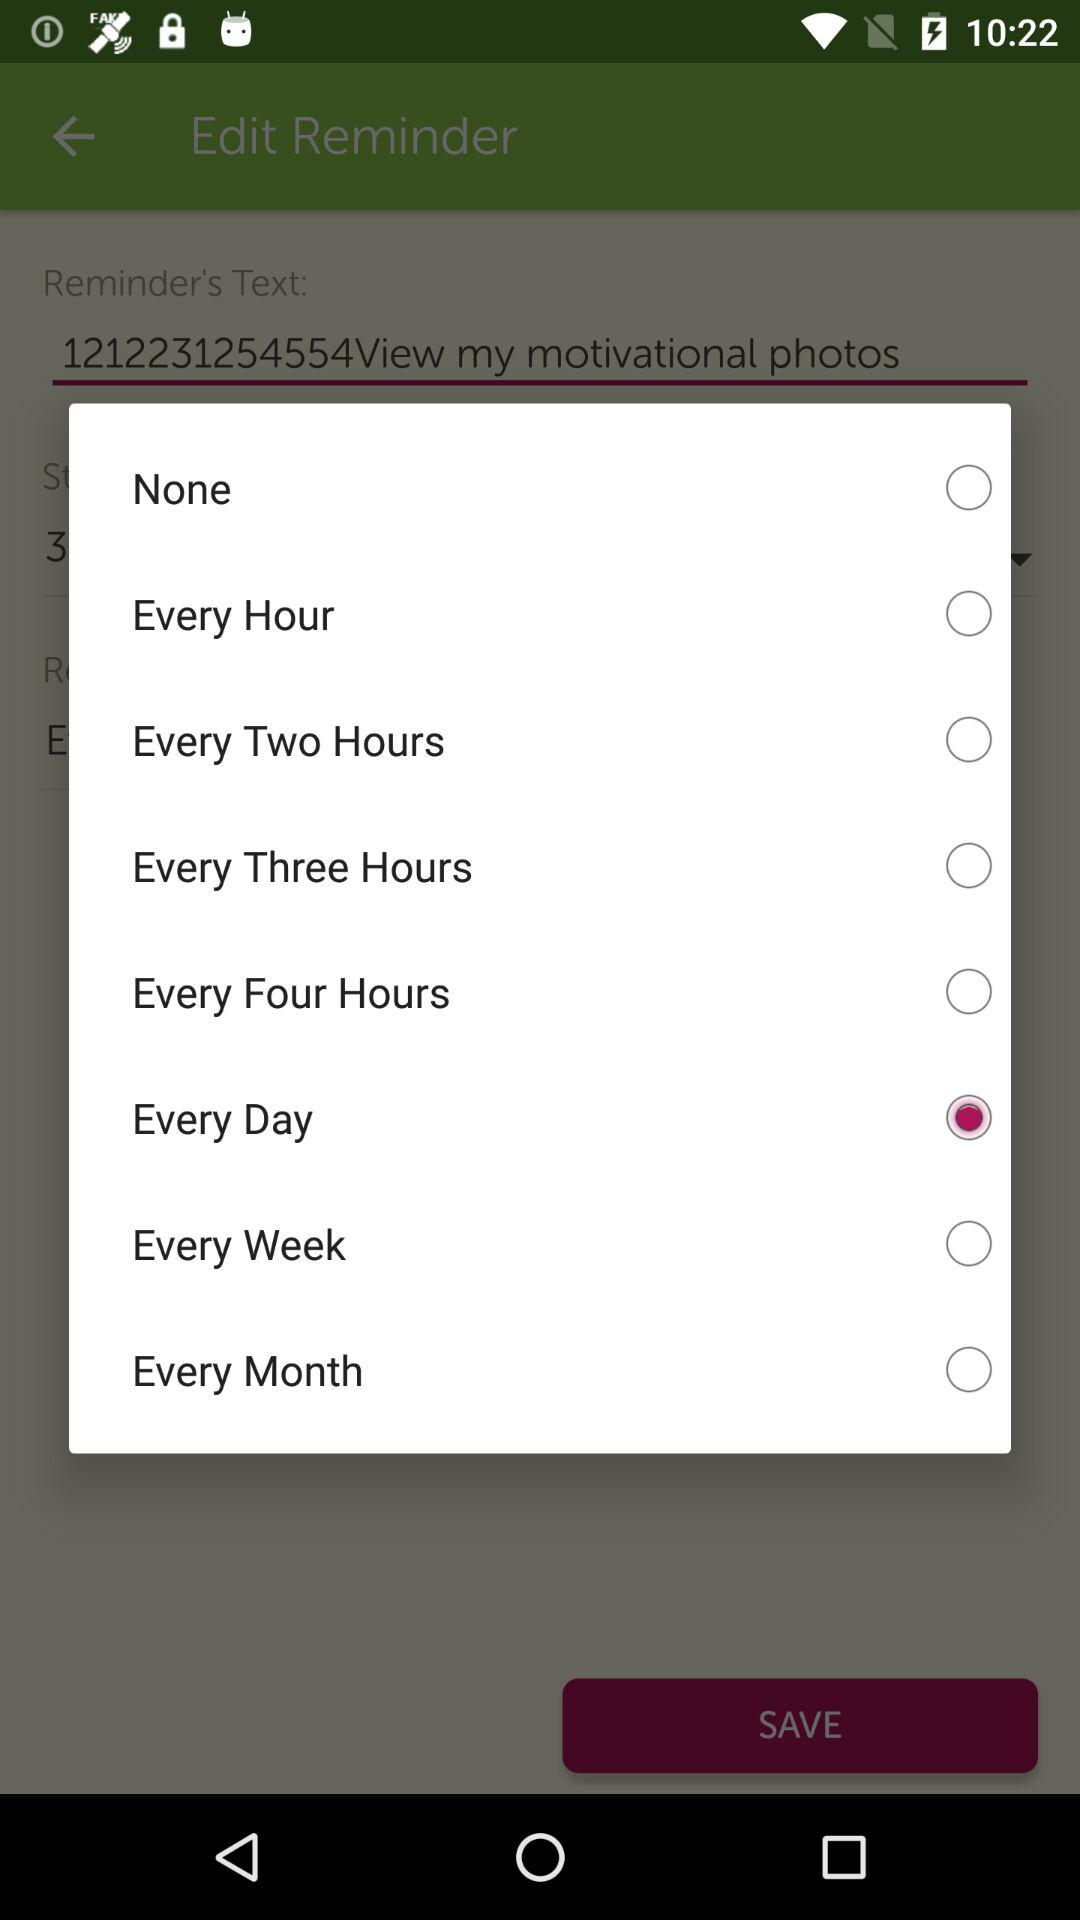What option has been selected? The selected option is "Every Day". 